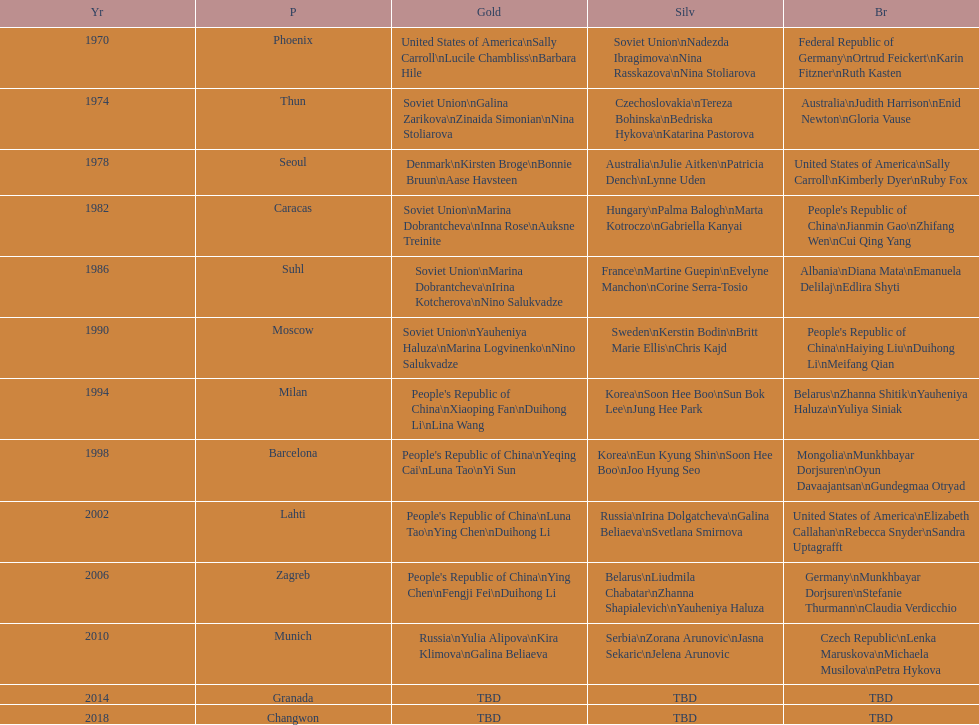How many times has germany won bronze? 2. 